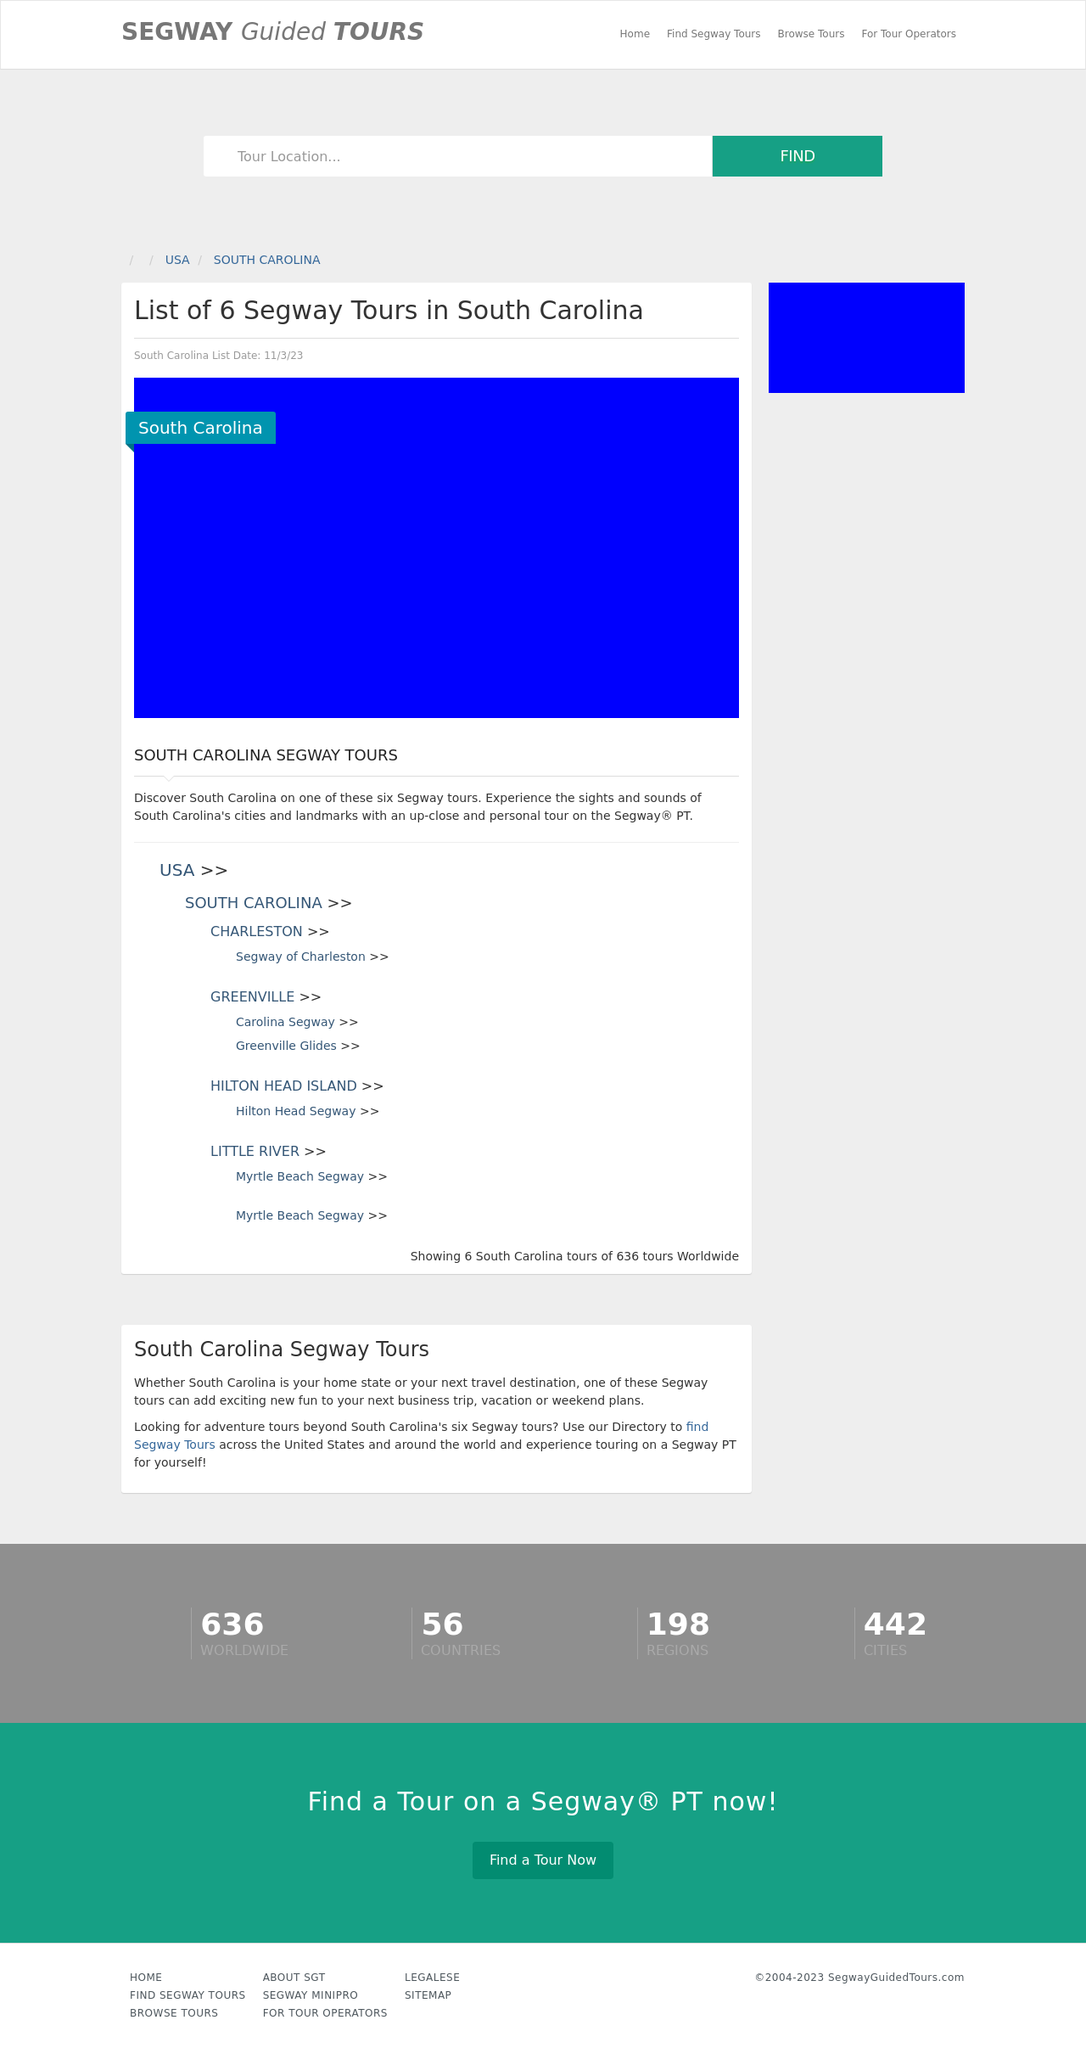Can you tell me more about the Segway tours offered in Charleston as shown in the image? Certainly! The website lists several Segway tours available in Charleston. These tours offer a unique way to explore the rich history and beautiful scenery of Charleston while riding on a Segway. From historical downtown tours that cover major landmarks to more themed adventures, each tour provides an exciting and educational experience about the local culture and architecture. Are there options for different skill levels or types of tours? Yes, the tours cater to various skill levels, from beginners to experienced Segway riders. Additionally, there are diverse types of tours available, including night tours, nature tours, and even culinary tours that combine the joy of Segway riding with sampling local cuisine. 